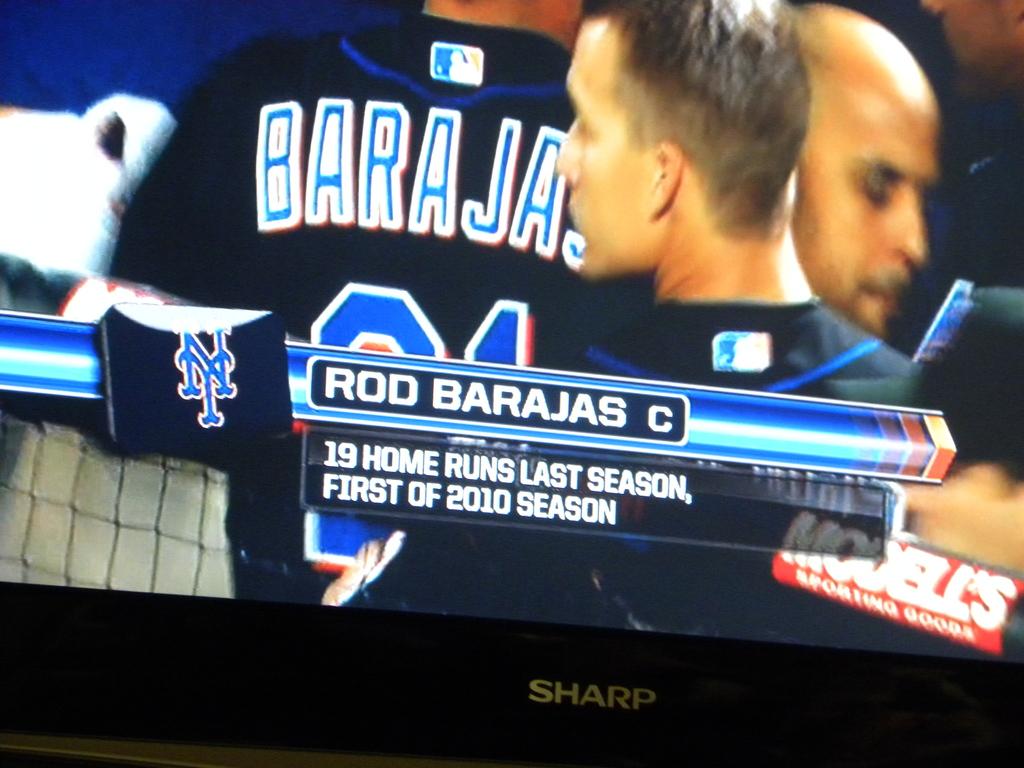How many home-runs does he have?
Provide a short and direct response. 19. What is the name of the player?
Offer a very short reply. Rod barajas. 